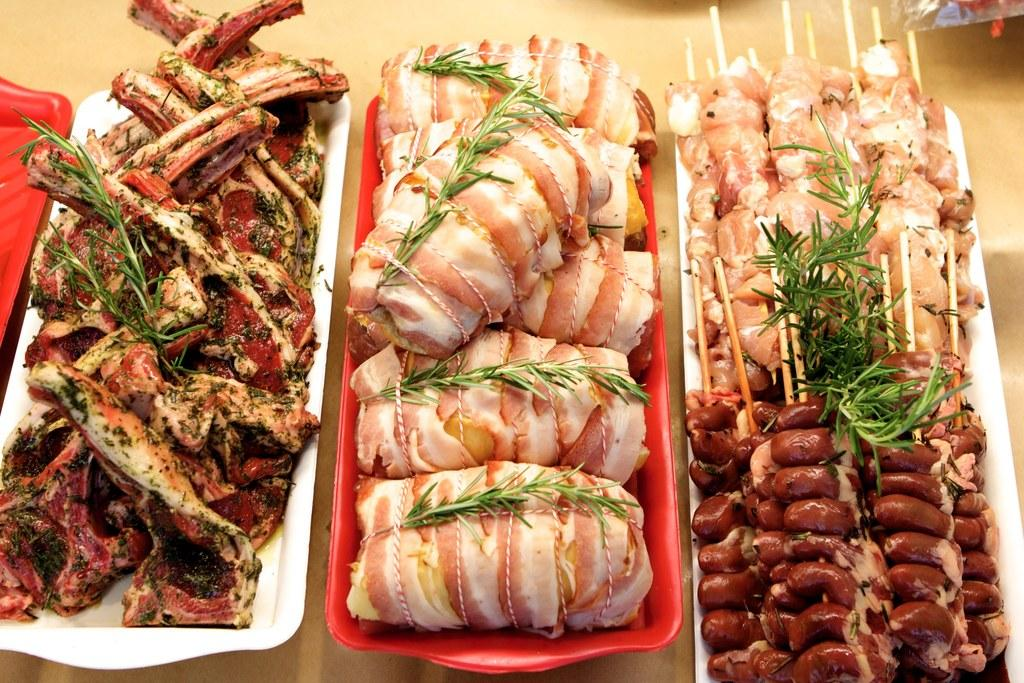What type of food can be seen in the image? The food in the image is in brown and green colors. What colors are the trays in the image? The trays are in white and red colors. Where are the food and trays located? The food and trays are on a table. Are there any bees buzzing around the food in the image? There is no mention of bees or any insects in the image, so we cannot determine if there are any bees present. 